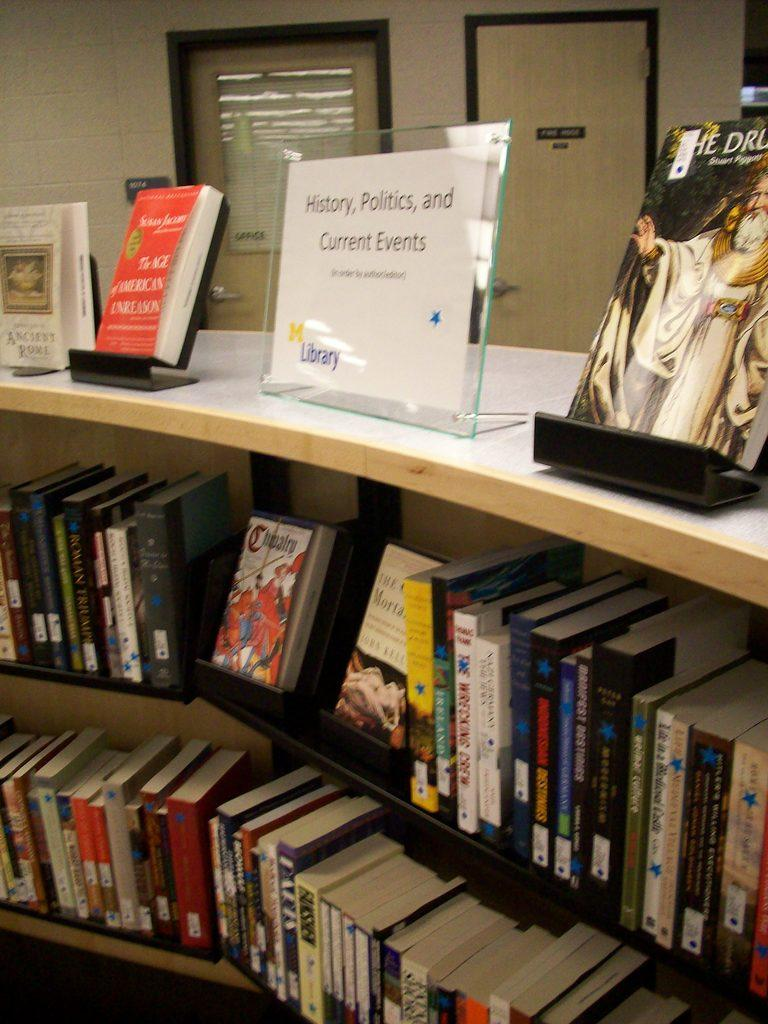What is the main subject of the image? The main subject of the image is many books. What else can be seen in the image besides the books? A name board is present in the image, and both the books and name board are placed in a cupboard. What can be seen in the background of the image? There are doors and a wall in the background of the image. What type of roof can be seen in the image? There is no roof present in the image; it features books, a name board, and a cupboard in front of a wall and doors. 